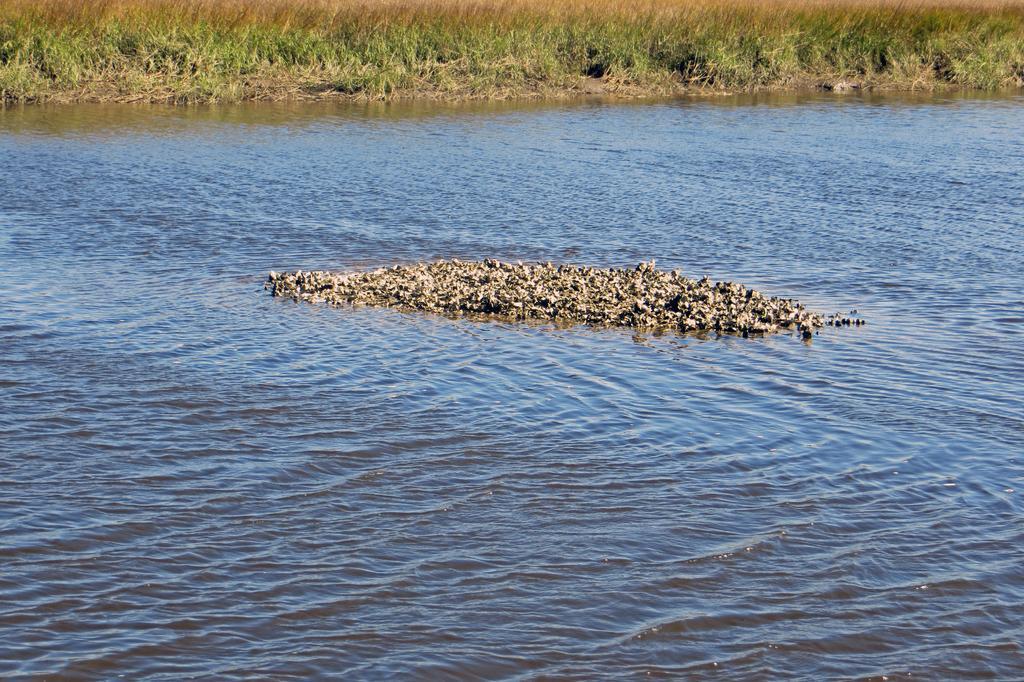How would you summarize this image in a sentence or two? In this image we can see some birds in the water, also we can see the grass. 